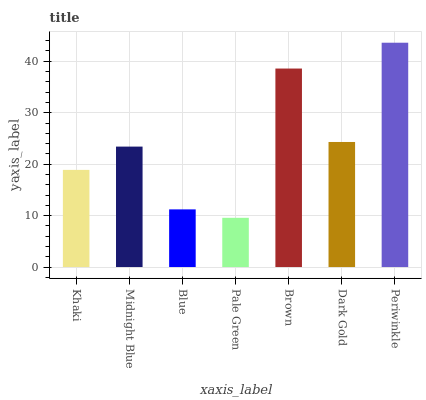Is Pale Green the minimum?
Answer yes or no. Yes. Is Periwinkle the maximum?
Answer yes or no. Yes. Is Midnight Blue the minimum?
Answer yes or no. No. Is Midnight Blue the maximum?
Answer yes or no. No. Is Midnight Blue greater than Khaki?
Answer yes or no. Yes. Is Khaki less than Midnight Blue?
Answer yes or no. Yes. Is Khaki greater than Midnight Blue?
Answer yes or no. No. Is Midnight Blue less than Khaki?
Answer yes or no. No. Is Midnight Blue the high median?
Answer yes or no. Yes. Is Midnight Blue the low median?
Answer yes or no. Yes. Is Periwinkle the high median?
Answer yes or no. No. Is Pale Green the low median?
Answer yes or no. No. 